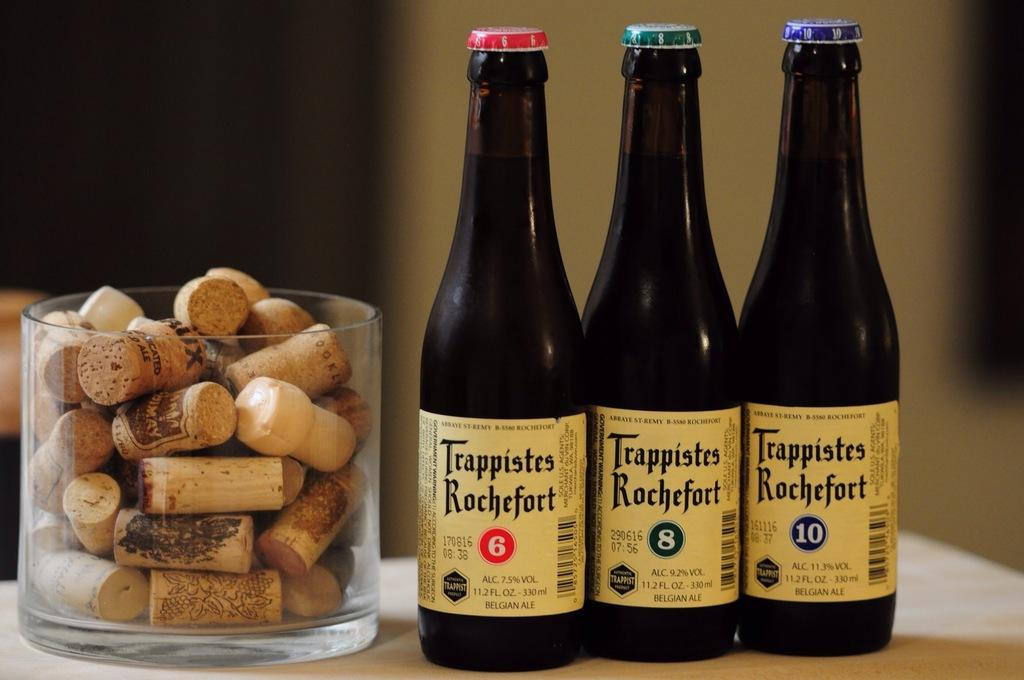Provide a one-sentence caption for the provided image. Bottles labeled 6, 8 and 10 are all made by Trappistes Rochefort. 